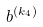<formula> <loc_0><loc_0><loc_500><loc_500>b ^ { ( k _ { 4 } ) }</formula> 